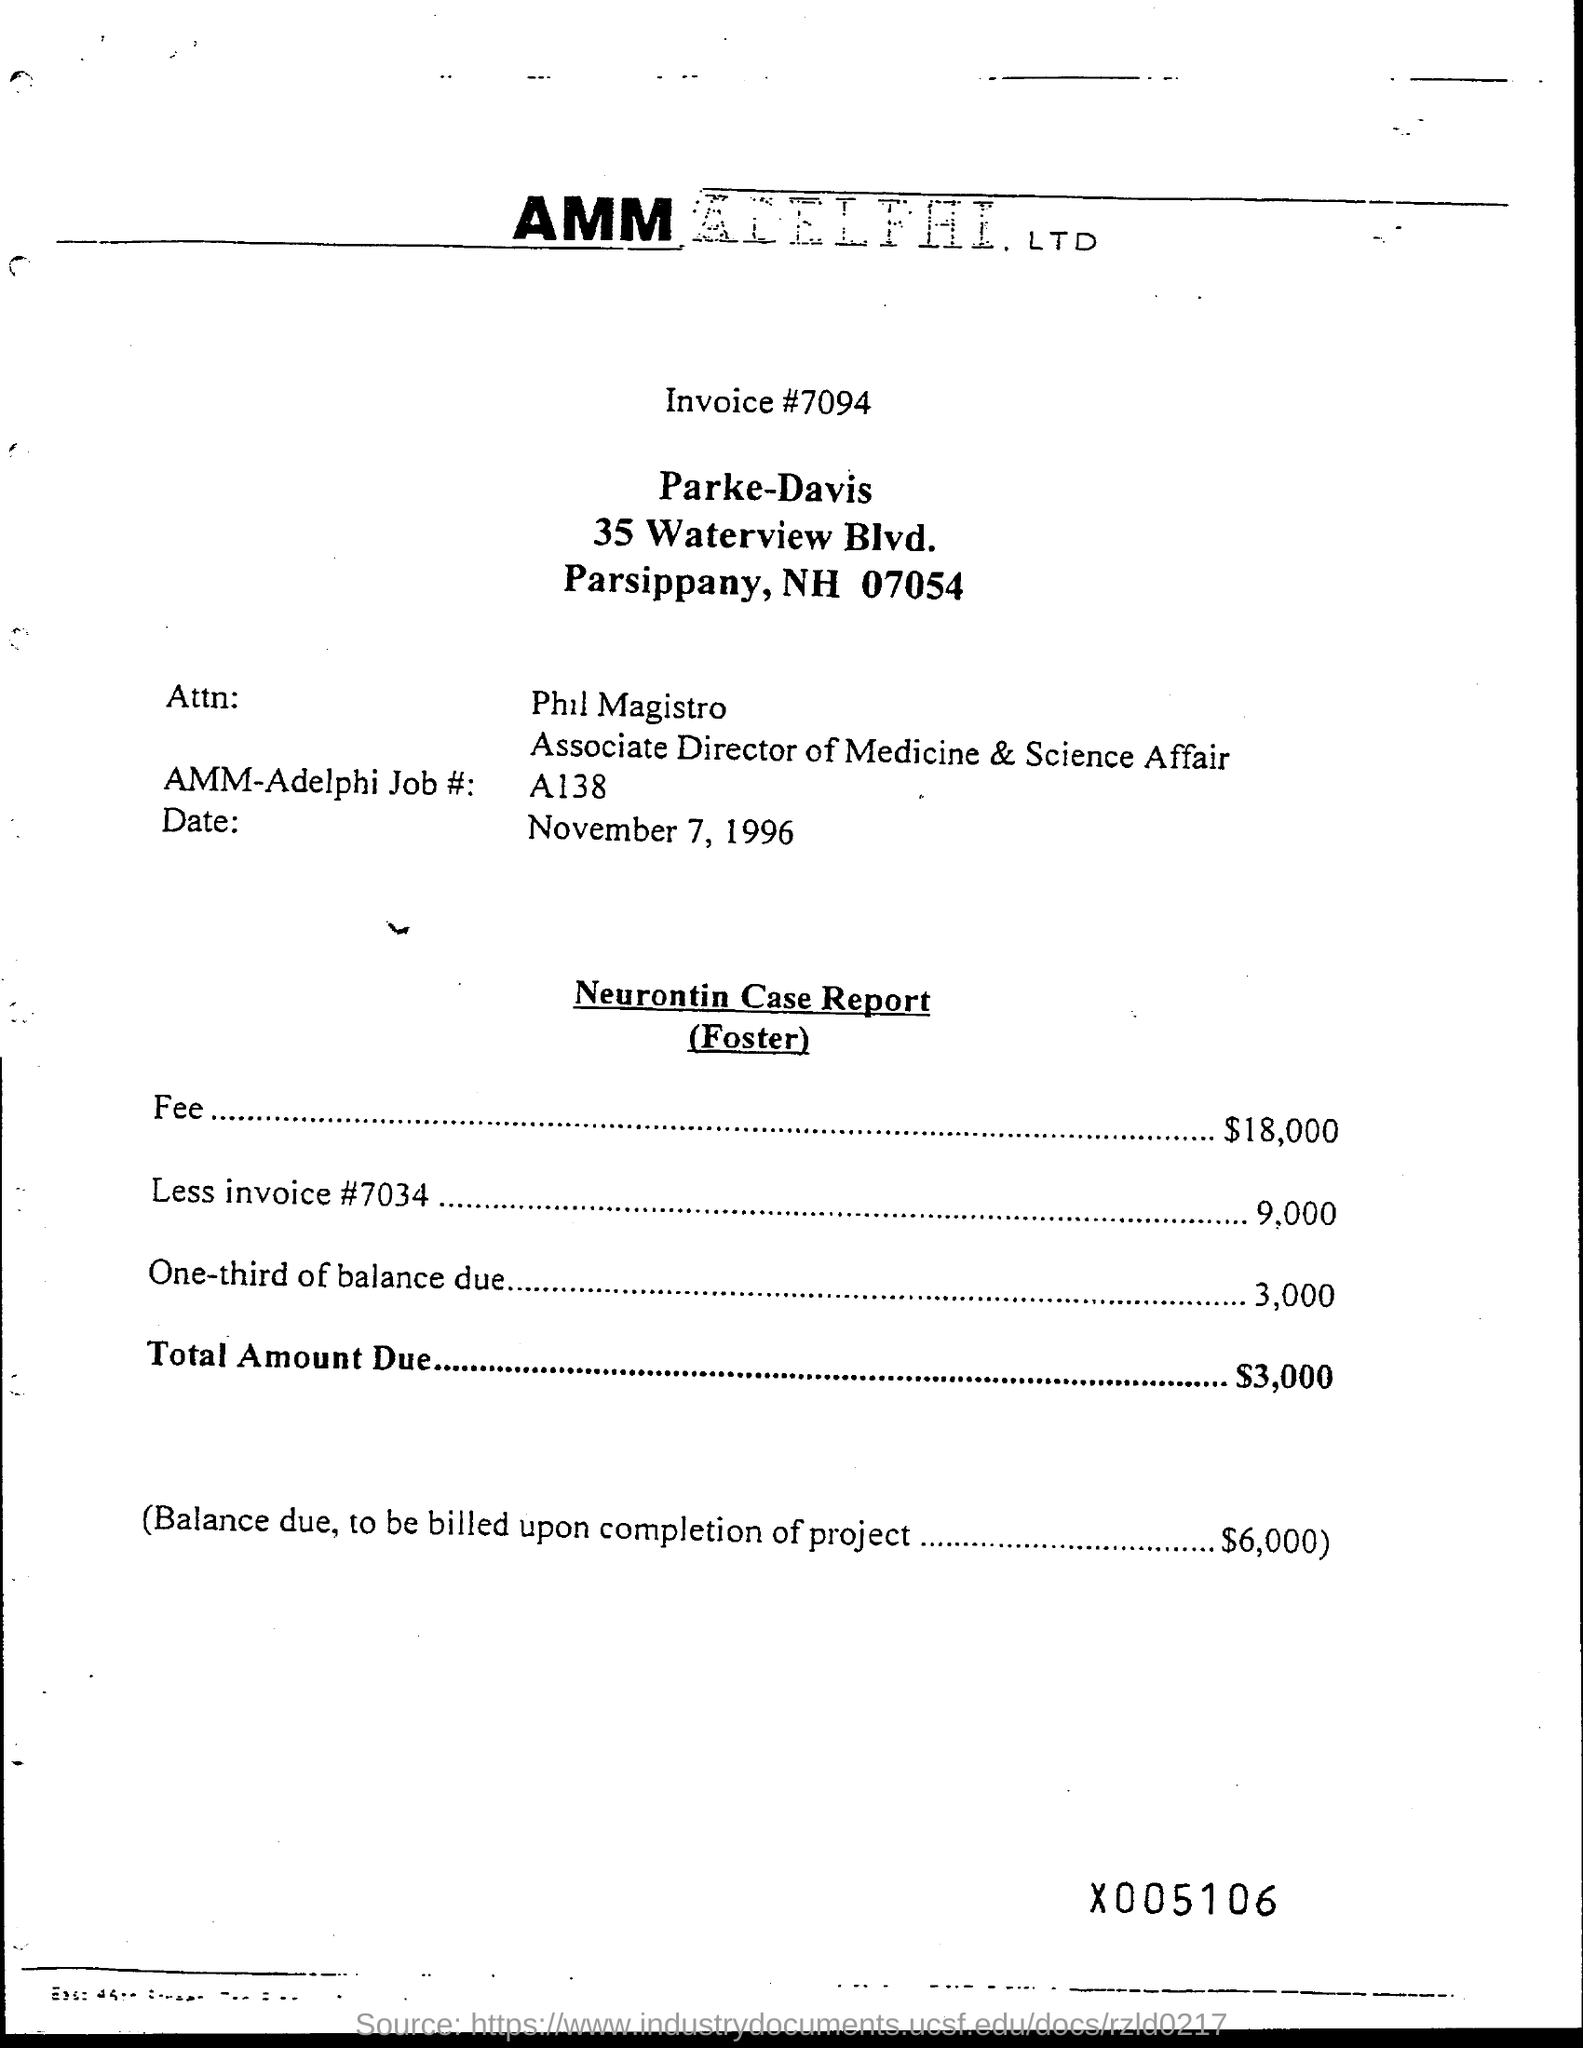Specify some key components in this picture. What is one-third of the balance due? 3,000..."? The fee amount is $18,000. The total amount due is $3,000. 